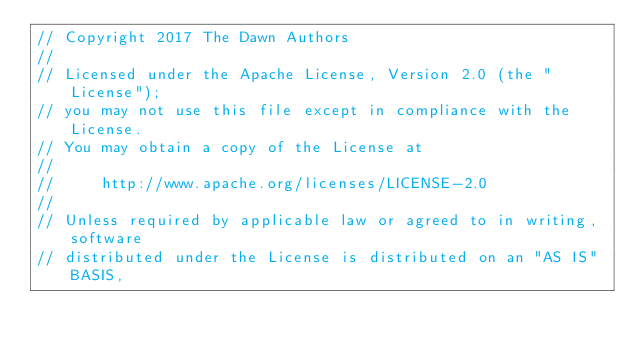Convert code to text. <code><loc_0><loc_0><loc_500><loc_500><_ObjectiveC_>// Copyright 2017 The Dawn Authors
//
// Licensed under the Apache License, Version 2.0 (the "License");
// you may not use this file except in compliance with the License.
// You may obtain a copy of the License at
//
//     http://www.apache.org/licenses/LICENSE-2.0
//
// Unless required by applicable law or agreed to in writing, software
// distributed under the License is distributed on an "AS IS" BASIS,</code> 